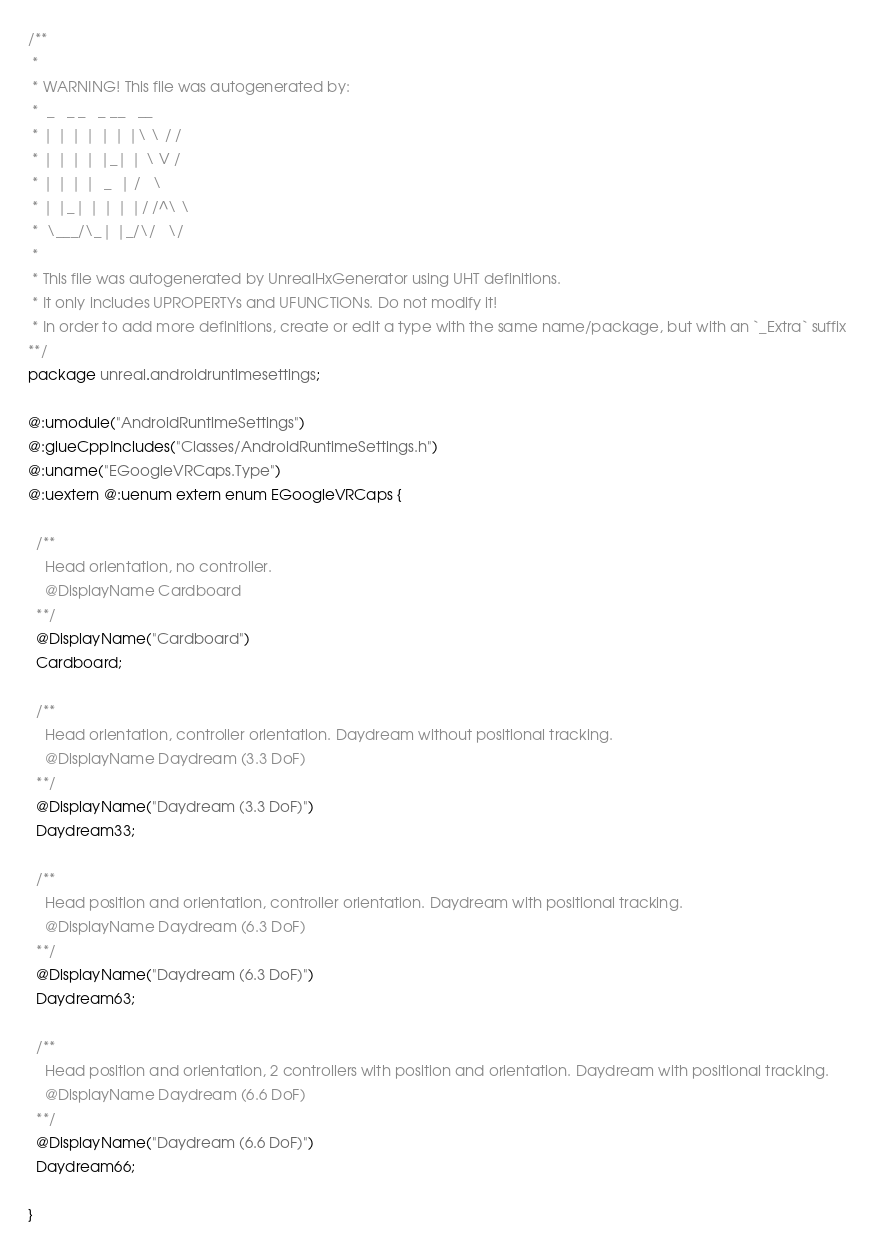<code> <loc_0><loc_0><loc_500><loc_500><_Haxe_>/**
 * 
 * WARNING! This file was autogenerated by: 
 *  _   _ _   _ __   __ 
 * | | | | | | |\ \ / / 
 * | | | | |_| | \ V /  
 * | | | |  _  | /   \  
 * | |_| | | | |/ /^\ \ 
 *  \___/\_| |_/\/   \/ 
 * 
 * This file was autogenerated by UnrealHxGenerator using UHT definitions.
 * It only includes UPROPERTYs and UFUNCTIONs. Do not modify it!
 * In order to add more definitions, create or edit a type with the same name/package, but with an `_Extra` suffix
**/
package unreal.androidruntimesettings;

@:umodule("AndroidRuntimeSettings")
@:glueCppIncludes("Classes/AndroidRuntimeSettings.h")
@:uname("EGoogleVRCaps.Type")
@:uextern @:uenum extern enum EGoogleVRCaps {
  
  /**
    Head orientation, no controller.
    @DisplayName Cardboard
  **/
  @DisplayName("Cardboard")
  Cardboard;
  
  /**
    Head orientation, controller orientation. Daydream without positional tracking.
    @DisplayName Daydream (3.3 DoF)
  **/
  @DisplayName("Daydream (3.3 DoF)")
  Daydream33;
  
  /**
    Head position and orientation, controller orientation. Daydream with positional tracking.
    @DisplayName Daydream (6.3 DoF)
  **/
  @DisplayName("Daydream (6.3 DoF)")
  Daydream63;
  
  /**
    Head position and orientation, 2 controllers with position and orientation. Daydream with positional tracking.
    @DisplayName Daydream (6.6 DoF)
  **/
  @DisplayName("Daydream (6.6 DoF)")
  Daydream66;
  
}
</code> 